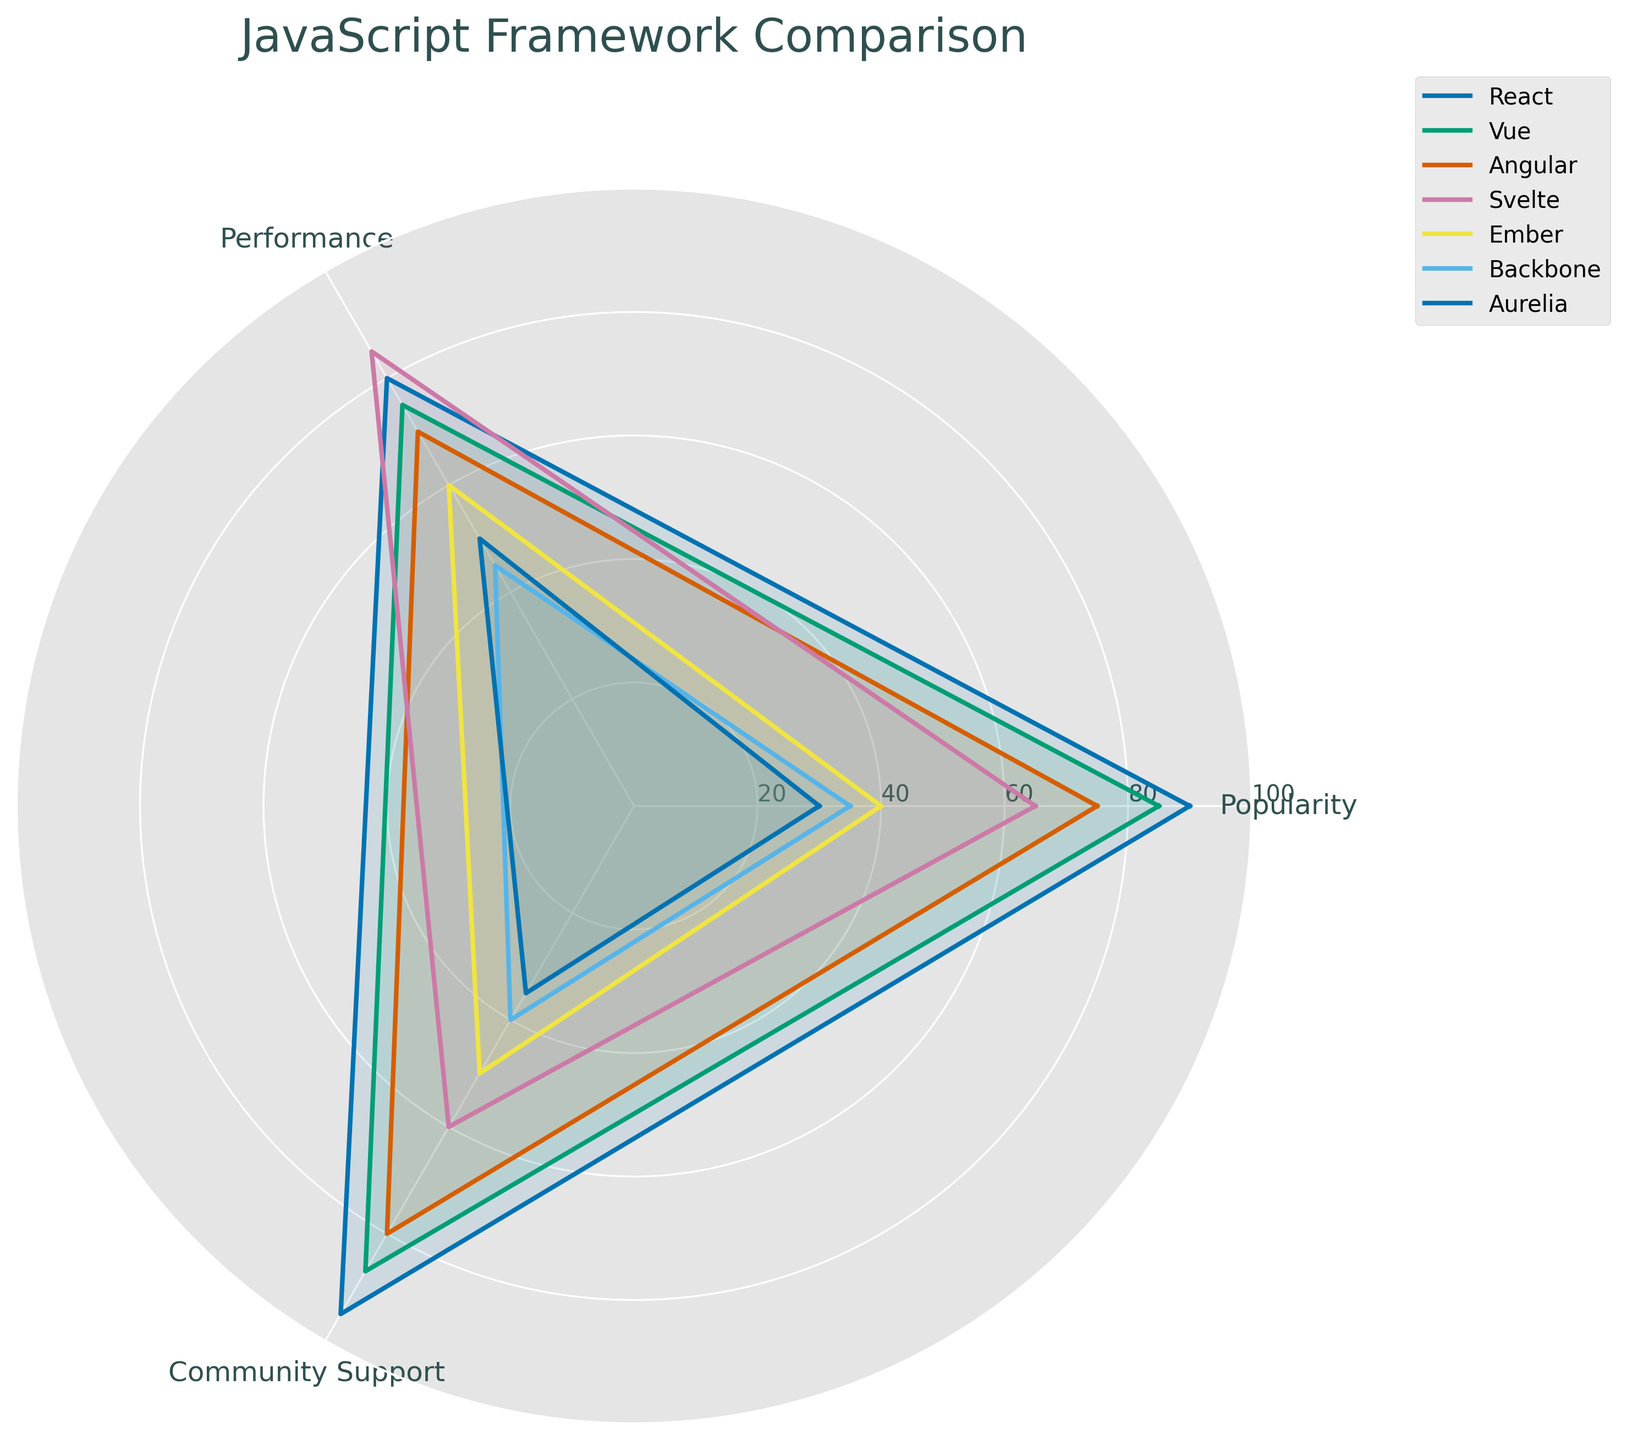Which framework has the highest popularity? By looking at the popularity metric on the radar chart, identify the framework with the highest value. React has the highest popularity score of 90.
Answer: React Which framework scores the lowest in performance? Review the performance scores for each framework on the radar chart. Backbone has the lowest performance score of 45.
Answer: Backbone What is the average community support score for React, Vue, and Angular? Add the community support scores for React (95), Vue (87), and Angular (80), then divide by 3. (95 + 87 + 80) / 3 = 262 / 3 ≈ 87.33
Answer: 87.33 Which two frameworks have the closest performance scores? Compare the performance scores for all frameworks. Vue (75) and Angular (70) have the closest performance scores, with a difference of 5.
Answer: Vue and Angular How does Svelte's popularity compare to Ember's? Compare the popularity scores for Svelte (65) and Ember (40). Svelte has a higher popularity score than Ember.
Answer: Svelte is more popular What is the sum of popularity scores for Backbone, Ember, and Aurelia? Add the popularity scores for Backbone (35), Ember (40), and Aurelia (30). 35 + 40 + 30 = 105
Answer: 105 Which framework shows the greatest variation between its highest and lowest metric? Calculate the variation for each framework by subtracting the lowest metric from the highest. React: 95-80=15, Vue: 87-75=12, Angular: 80-70=10, Svelte: 85-60=25, Ember: 60-40=20, Backbone: 45-35=10, Aurelia: 50-30=20. Svelte has the greatest variation of 25.
Answer: Svelte In terms of community support, which framework lags the most behind React? Compare community support scores. Aurelia has 35 and React has 95, so the difference is 95 - 35 = 60.
Answer: Aurelia What is the range of performance scores across all frameworks? Identify the highest and lowest performance scores (85 for Svelte and 45 for Backbone) and subtract the lowest from the highest. 85 - 45 = 40.
Answer: 40 